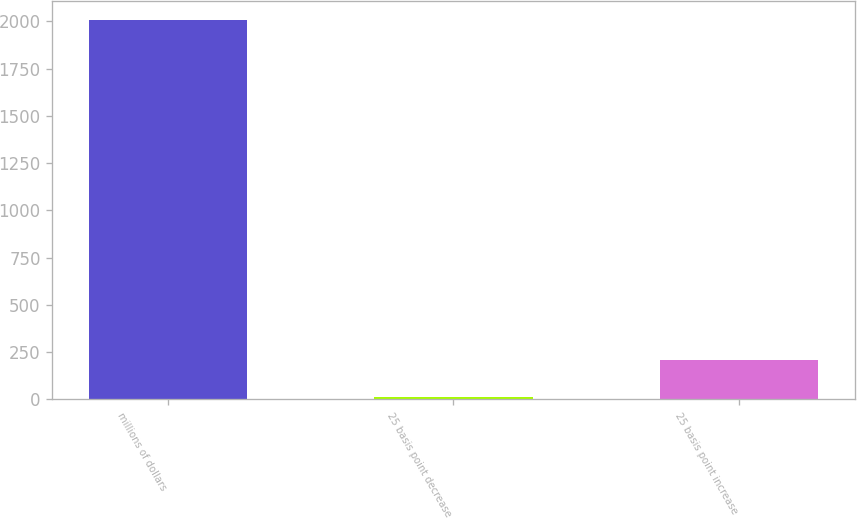Convert chart to OTSL. <chart><loc_0><loc_0><loc_500><loc_500><bar_chart><fcel>millions of dollars<fcel>25 basis point decrease<fcel>25 basis point increase<nl><fcel>2009<fcel>9.9<fcel>209.81<nl></chart> 